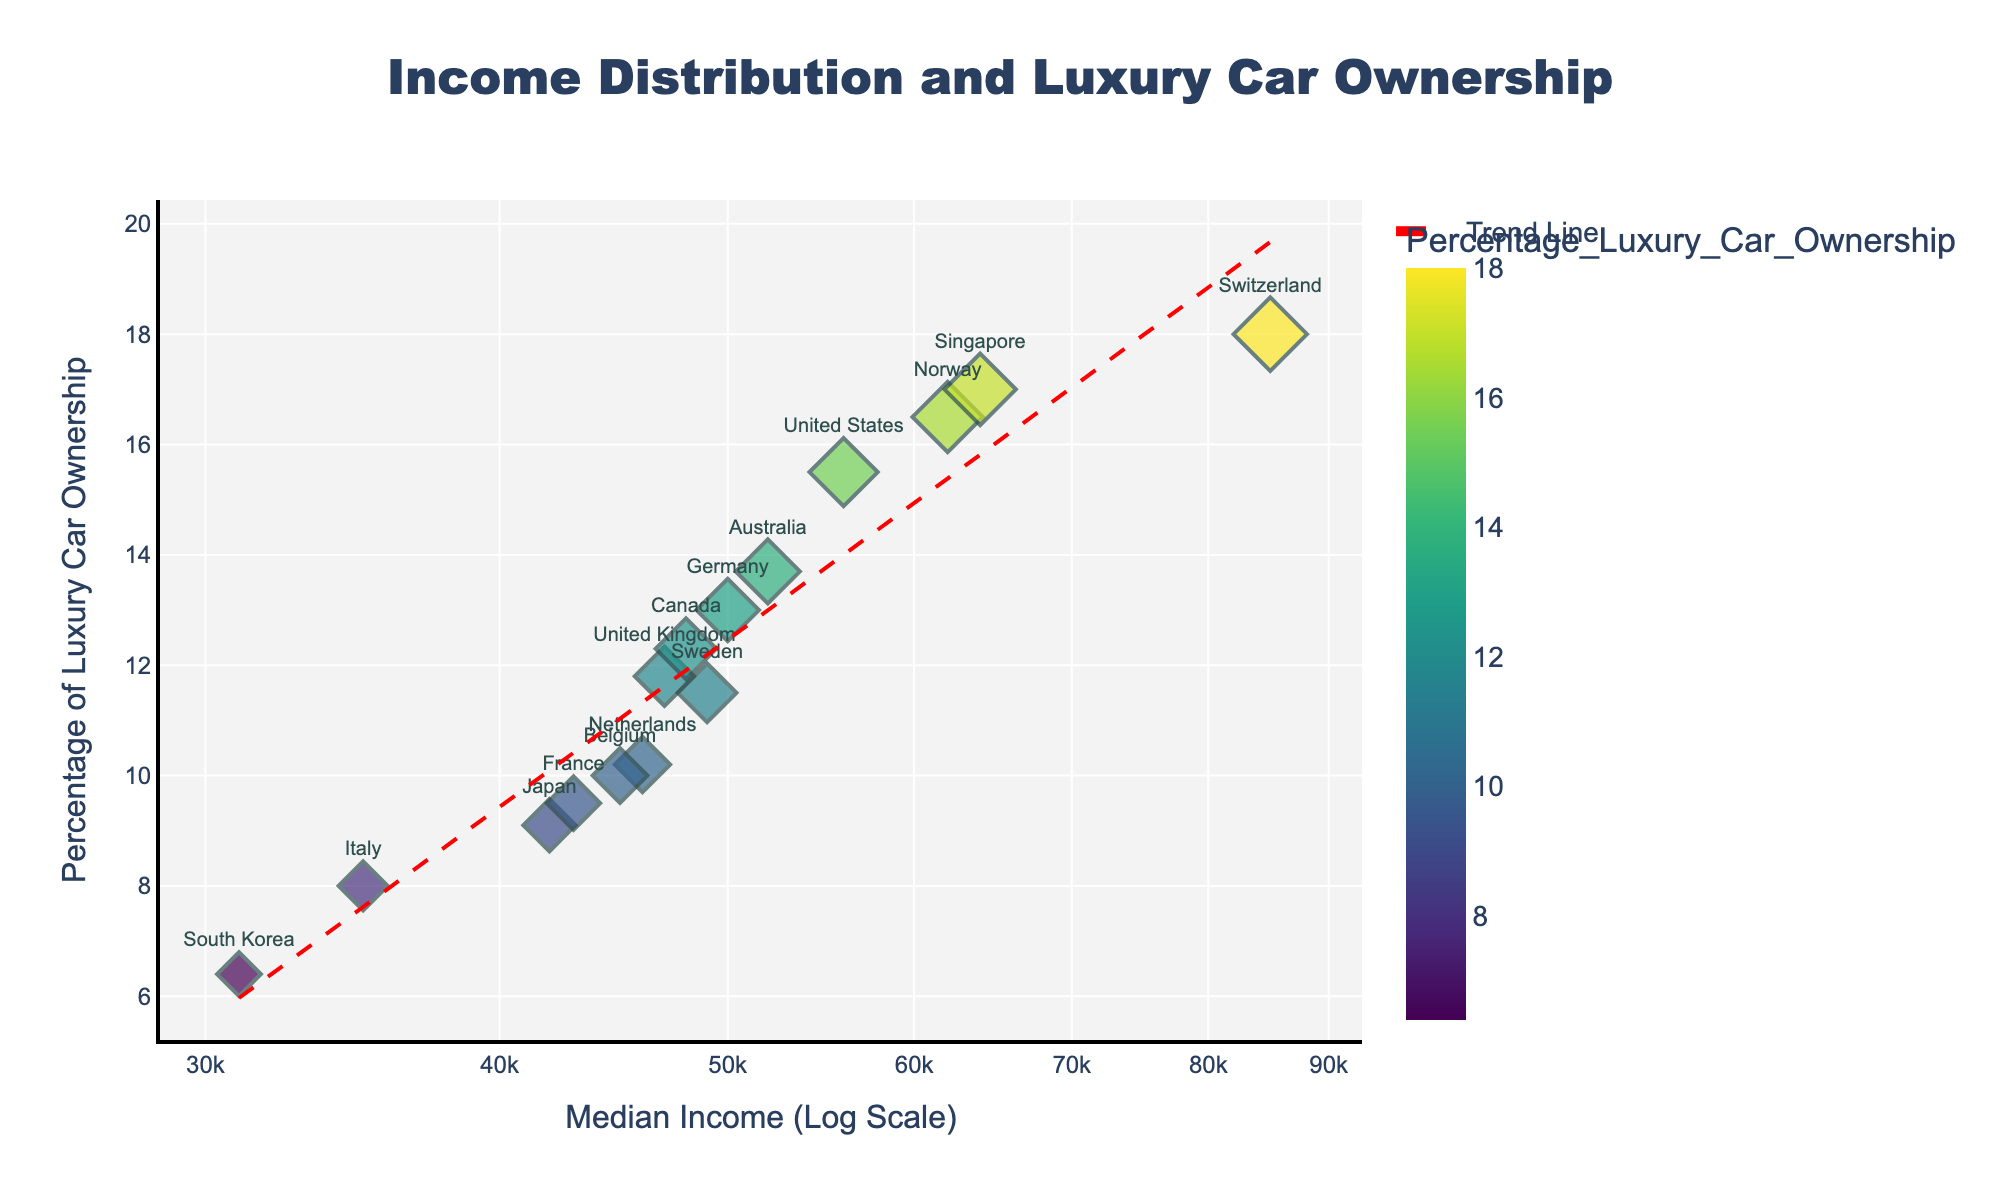What's the title of the figure? The title of the figure is displayed at the top and reads "Income Distribution and Luxury Car Ownership".
Answer: Income Distribution and Luxury Car Ownership What's the x-axis title in the figure? The x-axis title is shown below the x-axis and reads "Median Income (Log Scale)".
Answer: Median Income (Log Scale) Which country has the highest percentage of luxury car ownership? The figure clearly shows that Switzerland, the dot placed towards the higher end of the y-axis, has the highest percentage of 18.0%.
Answer: Switzerland Which countries have a median income greater than $50,000? By looking at the x-axis in the logarithmic scale, the countries with dots located to the right of the $50,000 marker are: United States, Australia, Norway, and Singapore.
Answer: United States, Australia, Norway, Singapore What is the general trend between median income and luxury car ownership percentage? By observing the trend line (dashed red line), it generally slopes upwards indicating a positive correlation between median income and the percentage of luxury car ownership.
Answer: Positive correlation Between Germany and the United Kingdom, which country has a higher median income and by how much? Germany's median income is plotted at $50,000 and the United Kingdom's is at $47,000. The difference is $50,000 - $47,000 = $3,000.
Answer: Germany, $3,000 Look at France and Japan, which one has a higher percentage of luxury car ownership and by how much? France's percentage of luxury car ownership is 9.5%, while Japan's is 9.1%. The difference is 9.5% - 9.1% = 0.4%.
Answer: France, 0.4% Which country has the lowest median income, and what is the value? The country with the dot farthest on the left side of the x-axis, corresponding to the lowest median income, is South Korea with a median income of $31,000.
Answer: South Korea, $31,000 Identify the country that not only has a high percentage of luxury car ownership but also stands out due to its significant outlier position in terms of income. The country Switzerland is represented as a significant outlier both in terms of the high percentage of luxury car ownership (18%) and a notably high median income ($85,000) compared to others.
Answer: Switzerland 